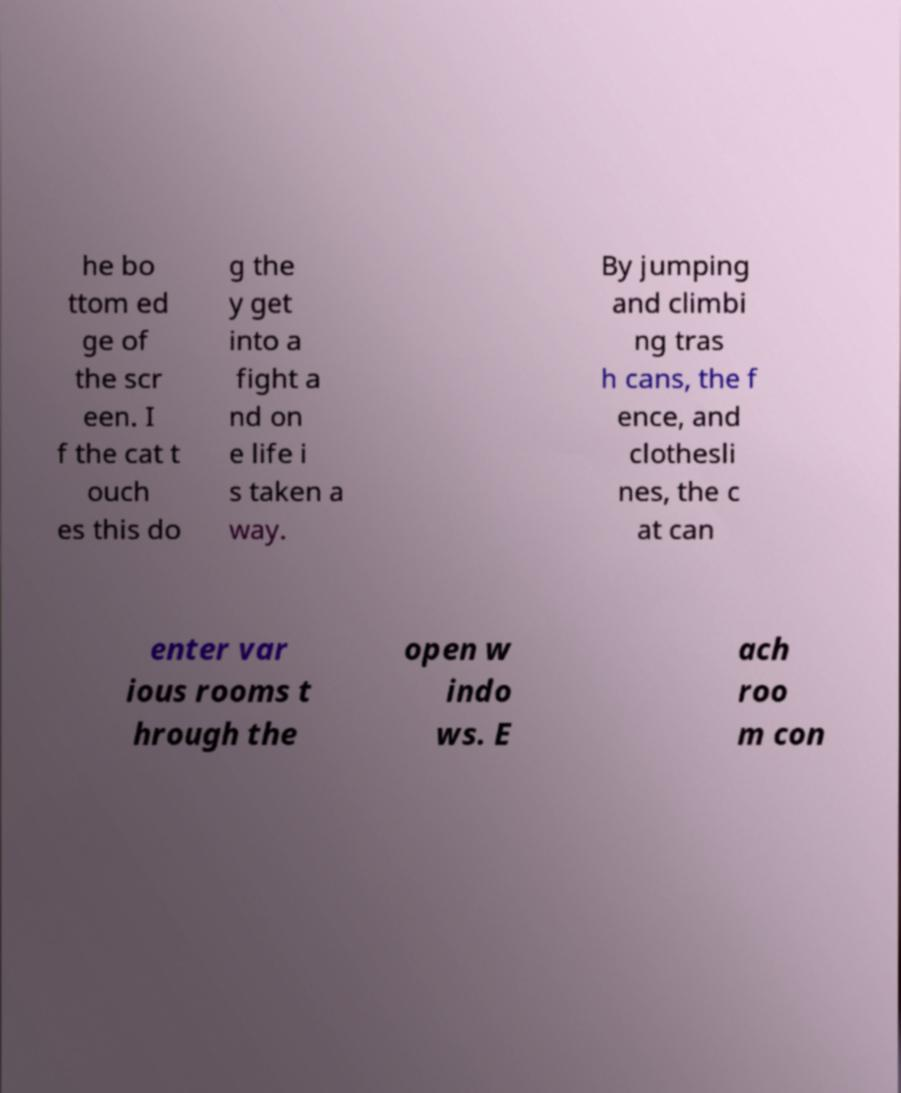Can you read and provide the text displayed in the image?This photo seems to have some interesting text. Can you extract and type it out for me? he bo ttom ed ge of the scr een. I f the cat t ouch es this do g the y get into a fight a nd on e life i s taken a way. By jumping and climbi ng tras h cans, the f ence, and clothesli nes, the c at can enter var ious rooms t hrough the open w indo ws. E ach roo m con 